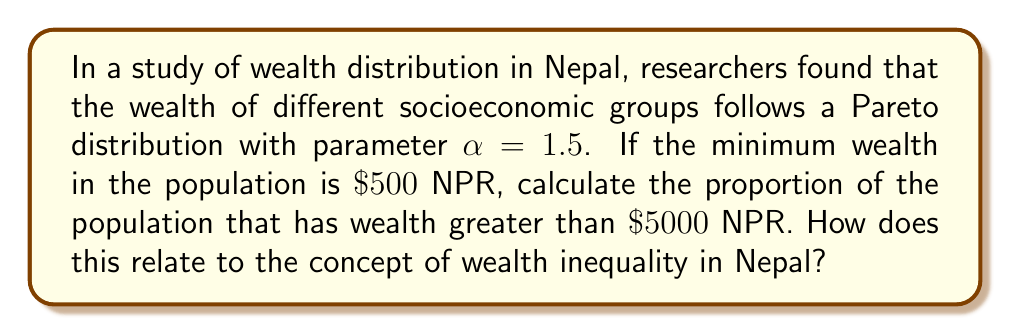Give your solution to this math problem. To solve this problem, we'll use the properties of the Pareto distribution and apply them to the given scenario:

1) The Pareto distribution's cumulative distribution function (CDF) is given by:

   $$F(x) = 1 - \left(\frac{x_m}{x}\right)^\alpha$$

   where $x_m$ is the minimum value (scale parameter) and $\alpha$ is the shape parameter.

2) We're interested in the probability that X > 5000, which is the complement of F(5000):

   $$P(X > 5000) = 1 - F(5000) = \left(\frac{x_m}{5000}\right)^\alpha$$

3) Given:
   - $x_m = 500$ NPR (minimum wealth)
   - $\alpha = 1.5$ (Pareto parameter)

4) Substituting these values:

   $$P(X > 5000) = \left(\frac{500}{5000}\right)^{1.5} = (0.1)^{1.5} = 0.1^{1.5}$$

5) Calculate:
   
   $$0.1^{1.5} = 0.0316227766$$

6) Convert to a percentage: 3.16%

This result indicates that approximately 3.16% of the population has wealth greater than 5000 NPR.

Relating to wealth inequality in Nepal:
This distribution shows a significant concentration of wealth in a small percentage of the population. The fact that only about 3.16% of people have more than 10 times the minimum wealth suggests a high level of wealth inequality. This type of analysis can be crucial for policymakers and social justice advocates in Nepal to understand and address economic disparities.
Answer: Approximately 3.16% of the population has wealth greater than 5000 NPR, indicating significant wealth inequality in Nepal. 